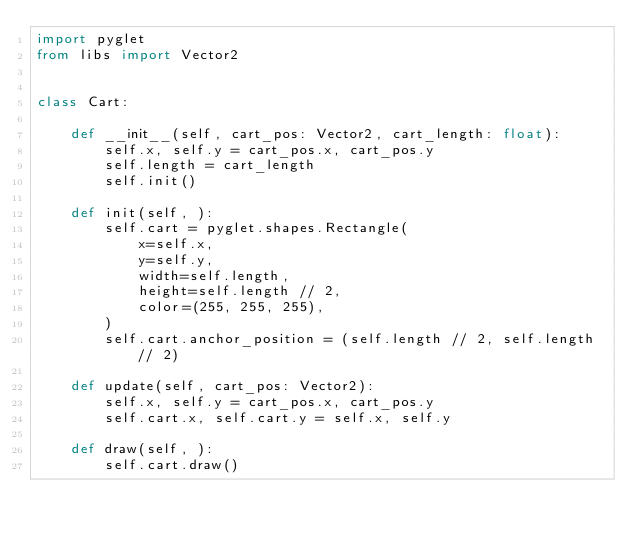<code> <loc_0><loc_0><loc_500><loc_500><_Python_>import pyglet
from libs import Vector2


class Cart:

    def __init__(self, cart_pos: Vector2, cart_length: float):
        self.x, self.y = cart_pos.x, cart_pos.y
        self.length = cart_length
        self.init()

    def init(self, ):
        self.cart = pyglet.shapes.Rectangle(
            x=self.x,
            y=self.y,
            width=self.length,
            height=self.length // 2,
            color=(255, 255, 255),
        )
        self.cart.anchor_position = (self.length // 2, self.length // 2)

    def update(self, cart_pos: Vector2):
        self.x, self.y = cart_pos.x, cart_pos.y
        self.cart.x, self.cart.y = self.x, self.y

    def draw(self, ):
        self.cart.draw()
</code> 